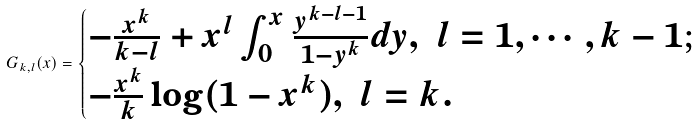<formula> <loc_0><loc_0><loc_500><loc_500>G _ { k , l } ( x ) = \begin{cases} - \frac { x ^ { k } } { k - l } + x ^ { l } \int _ { 0 } ^ { x } \frac { y ^ { k - l - 1 } } { 1 - y ^ { k } } d y , \ l = 1 , \cdots , k - 1 ; \\ - \frac { x ^ { k } } k \log ( 1 - x ^ { k } ) , \ l = k . \end{cases}</formula> 